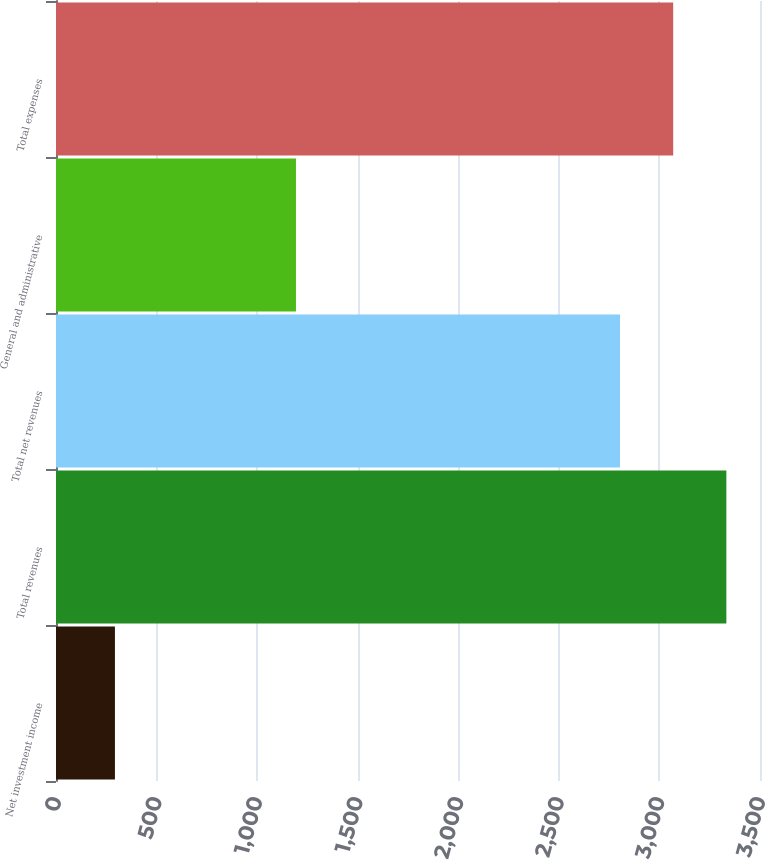<chart> <loc_0><loc_0><loc_500><loc_500><bar_chart><fcel>Net investment income<fcel>Total revenues<fcel>Total net revenues<fcel>General and administrative<fcel>Total expenses<nl><fcel>293<fcel>3332.8<fcel>2804<fcel>1193<fcel>3068.4<nl></chart> 